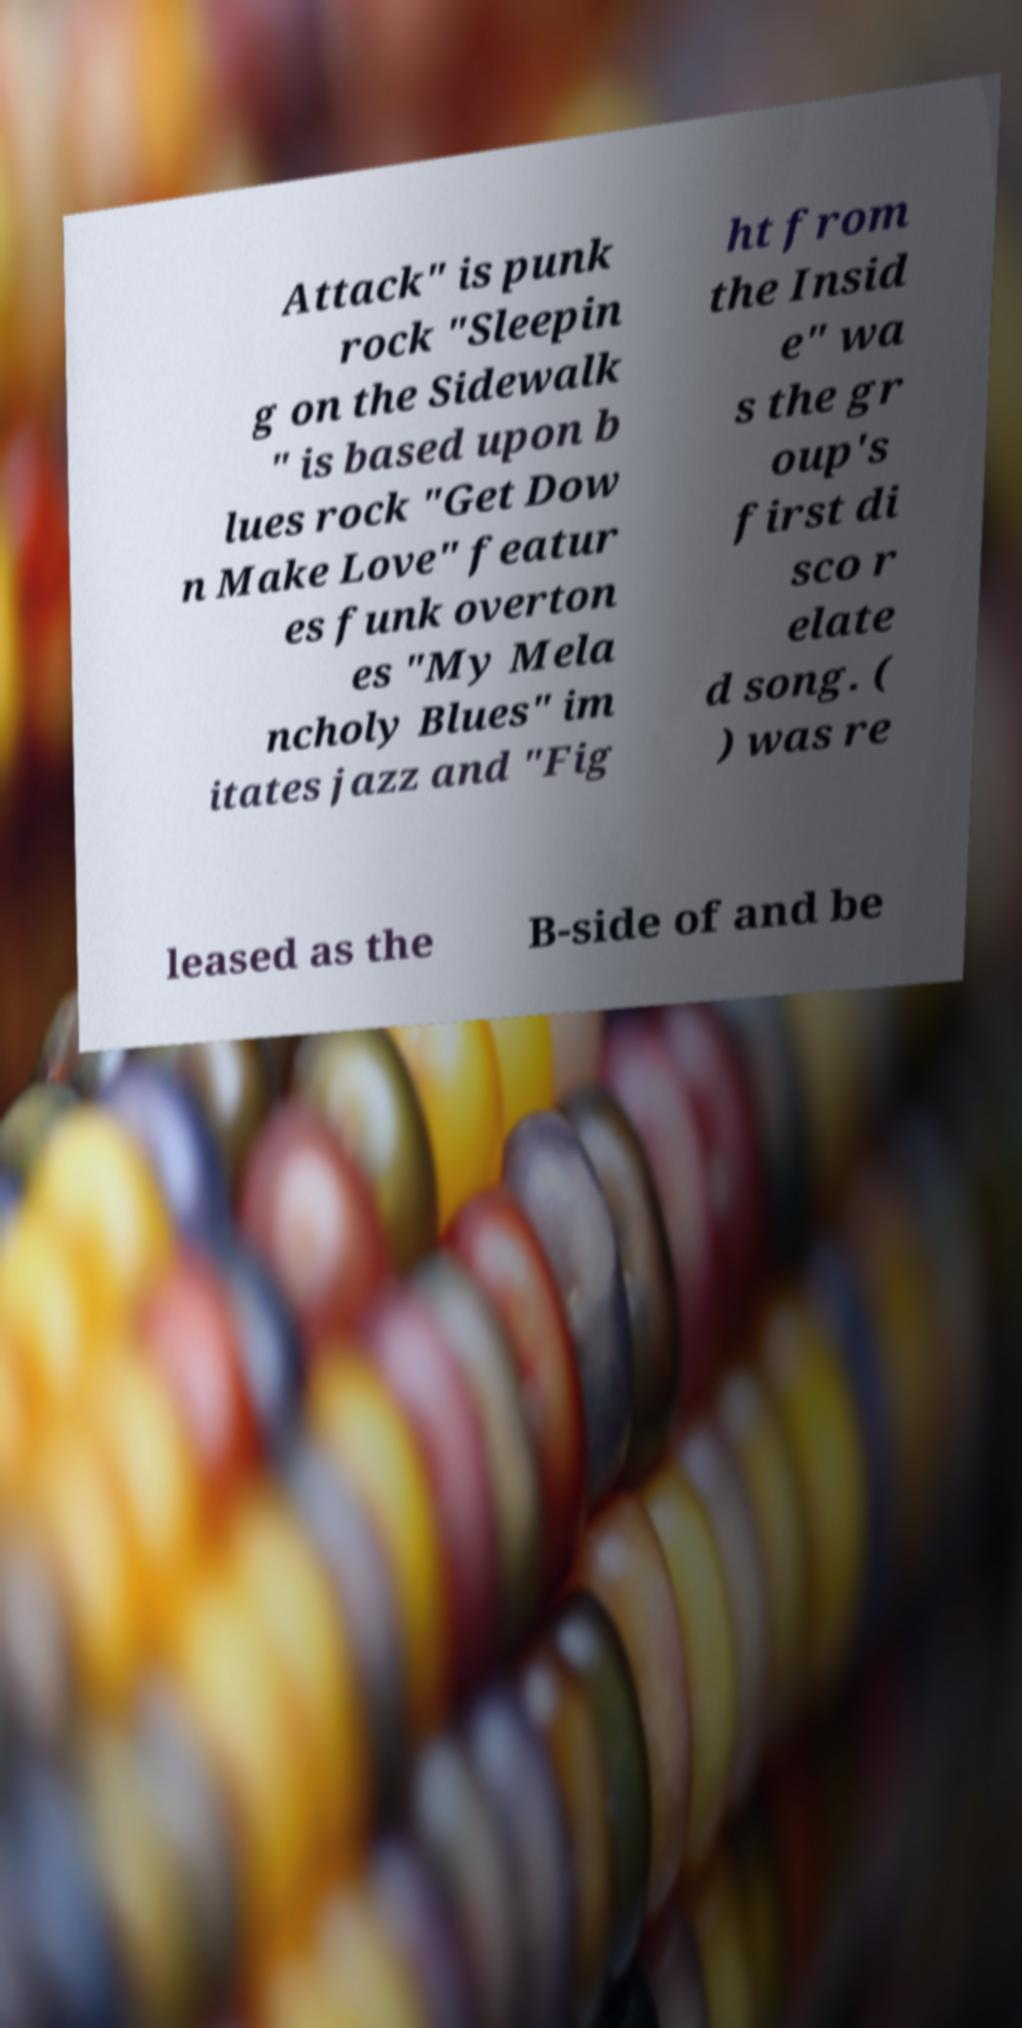Can you read and provide the text displayed in the image?This photo seems to have some interesting text. Can you extract and type it out for me? Attack" is punk rock "Sleepin g on the Sidewalk " is based upon b lues rock "Get Dow n Make Love" featur es funk overton es "My Mela ncholy Blues" im itates jazz and "Fig ht from the Insid e" wa s the gr oup's first di sco r elate d song. ( ) was re leased as the B-side of and be 